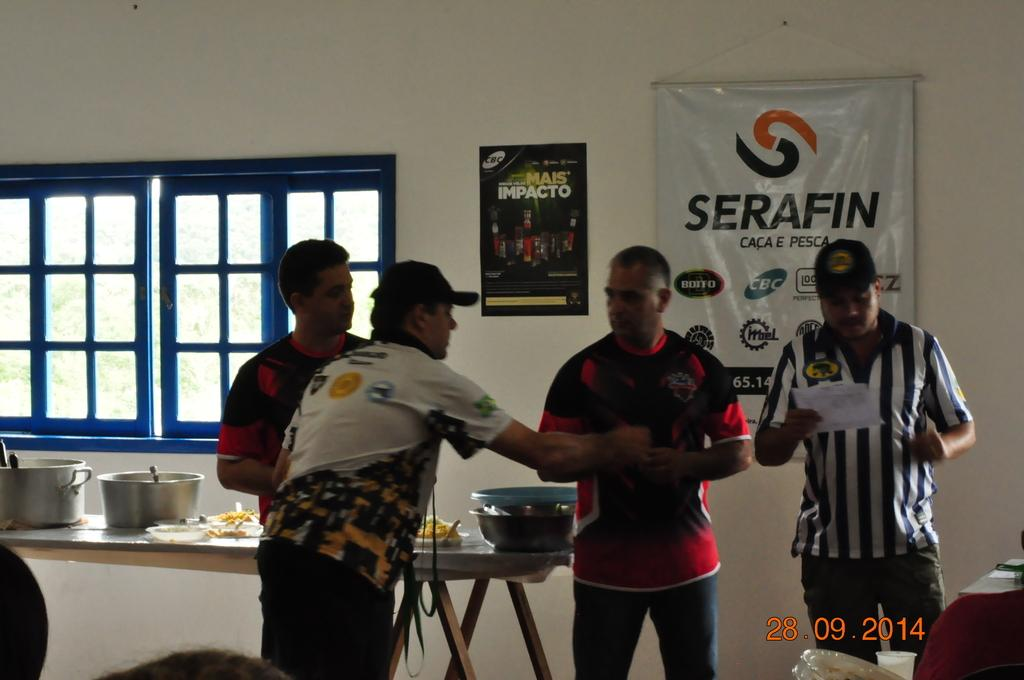<image>
Present a compact description of the photo's key features. A Serafin poster is on the wall behind the men. 